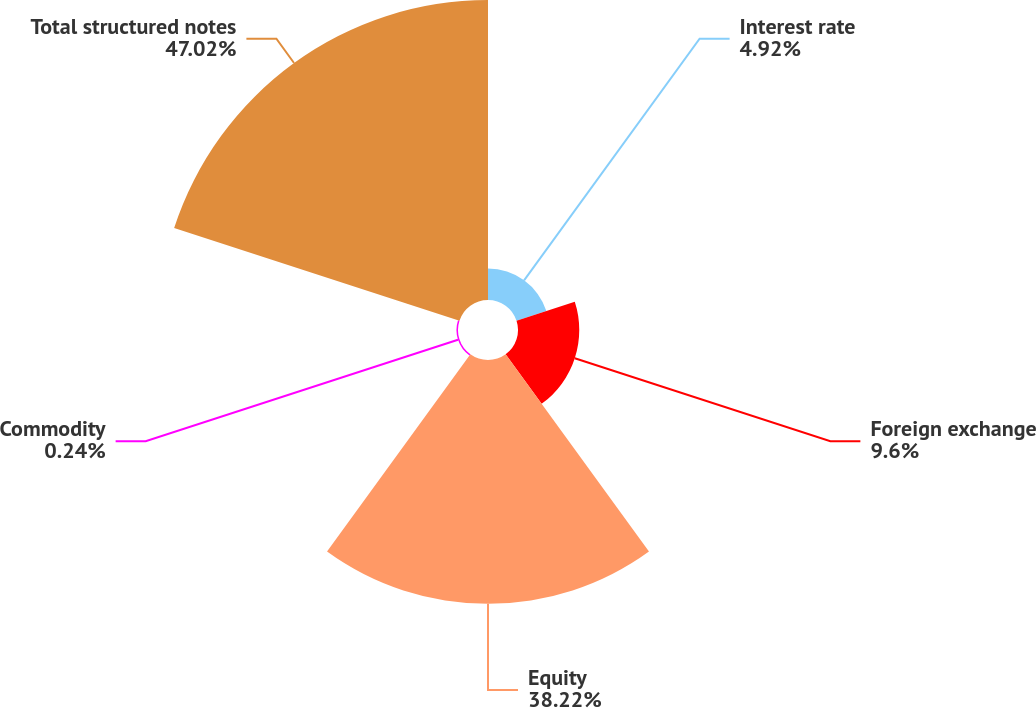<chart> <loc_0><loc_0><loc_500><loc_500><pie_chart><fcel>Interest rate<fcel>Foreign exchange<fcel>Equity<fcel>Commodity<fcel>Total structured notes<nl><fcel>4.92%<fcel>9.6%<fcel>38.22%<fcel>0.24%<fcel>47.02%<nl></chart> 